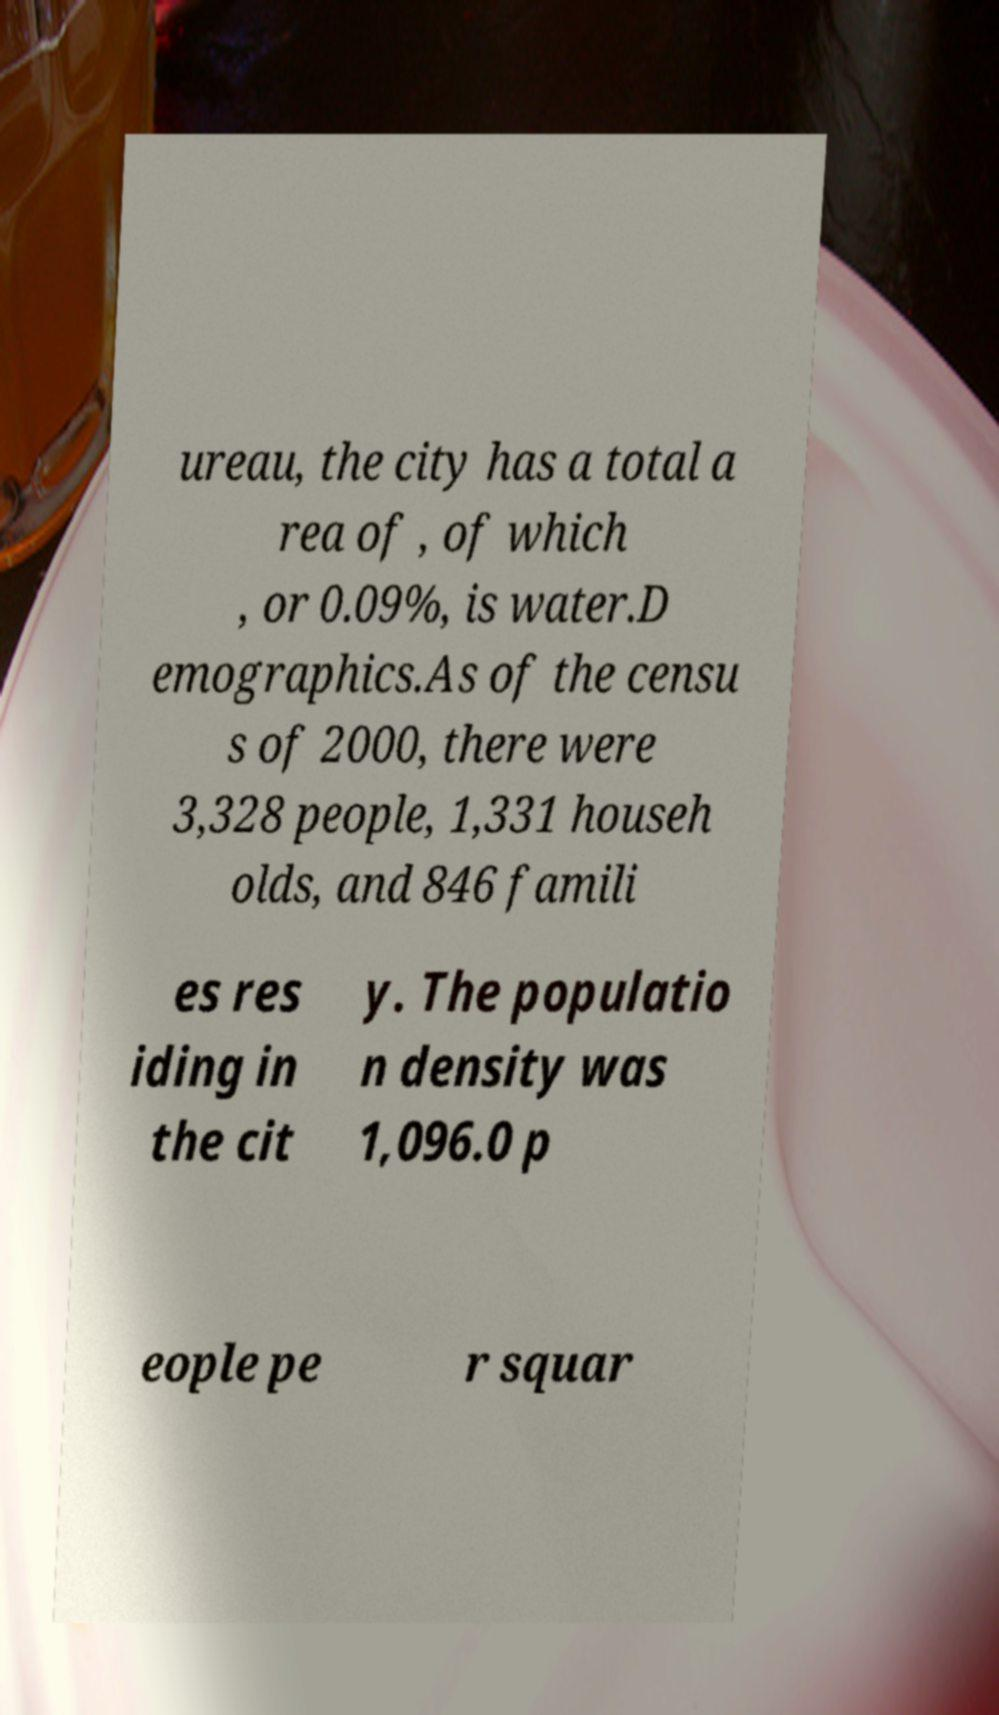I need the written content from this picture converted into text. Can you do that? ureau, the city has a total a rea of , of which , or 0.09%, is water.D emographics.As of the censu s of 2000, there were 3,328 people, 1,331 househ olds, and 846 famili es res iding in the cit y. The populatio n density was 1,096.0 p eople pe r squar 